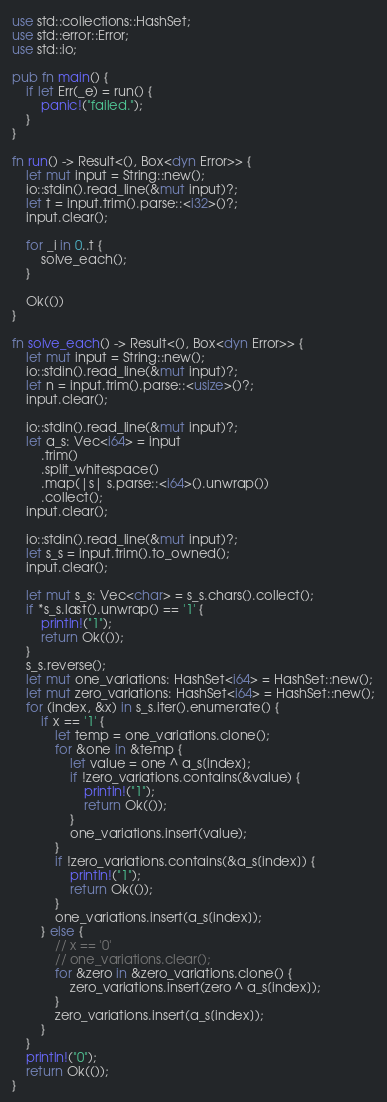<code> <loc_0><loc_0><loc_500><loc_500><_Rust_>use std::collections::HashSet;
use std::error::Error;
use std::io;

pub fn main() {
    if let Err(_e) = run() {
        panic!("failed.");
    }
}

fn run() -> Result<(), Box<dyn Error>> {
    let mut input = String::new();
    io::stdin().read_line(&mut input)?;
    let t = input.trim().parse::<i32>()?;
    input.clear();

    for _i in 0..t {
        solve_each();
    }

    Ok(())
}

fn solve_each() -> Result<(), Box<dyn Error>> {
    let mut input = String::new();
    io::stdin().read_line(&mut input)?;
    let n = input.trim().parse::<usize>()?;
    input.clear();

    io::stdin().read_line(&mut input)?;
    let a_s: Vec<i64> = input
        .trim()
        .split_whitespace()
        .map(|s| s.parse::<i64>().unwrap())
        .collect();
    input.clear();

    io::stdin().read_line(&mut input)?;
    let s_s = input.trim().to_owned();
    input.clear();

    let mut s_s: Vec<char> = s_s.chars().collect();
    if *s_s.last().unwrap() == '1' {
        println!("1");
        return Ok(());
    }
    s_s.reverse();
    let mut one_variations: HashSet<i64> = HashSet::new();
    let mut zero_variations: HashSet<i64> = HashSet::new();
    for (index, &x) in s_s.iter().enumerate() {
        if x == '1' {
            let temp = one_variations.clone();
            for &one in &temp {
                let value = one ^ a_s[index];
                if !zero_variations.contains(&value) {
                    println!("1");
                    return Ok(());
                }
                one_variations.insert(value);
            }
            if !zero_variations.contains(&a_s[index]) {
                println!("1");
                return Ok(());
            }
            one_variations.insert(a_s[index]);
        } else {
            // x == '0'
            // one_variations.clear();
            for &zero in &zero_variations.clone() {
                zero_variations.insert(zero ^ a_s[index]);
            }
            zero_variations.insert(a_s[index]);
        }
    }
    println!("0");
    return Ok(());
}
</code> 